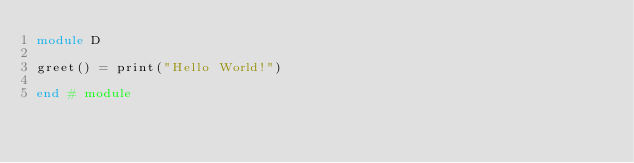Convert code to text. <code><loc_0><loc_0><loc_500><loc_500><_Julia_>module D

greet() = print("Hello World!")

end # module
</code> 